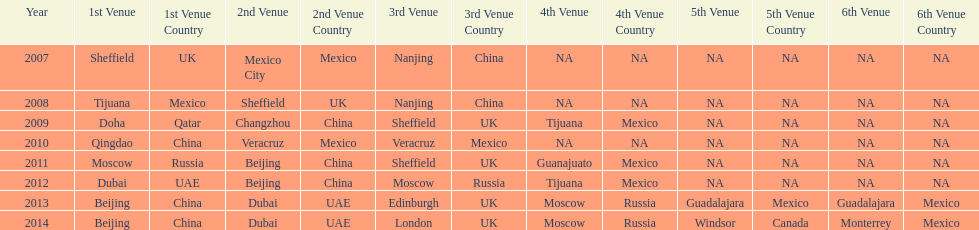In list of venues, how many years was beijing above moscow (1st venue is above 2nd venue, etc)? 3. 